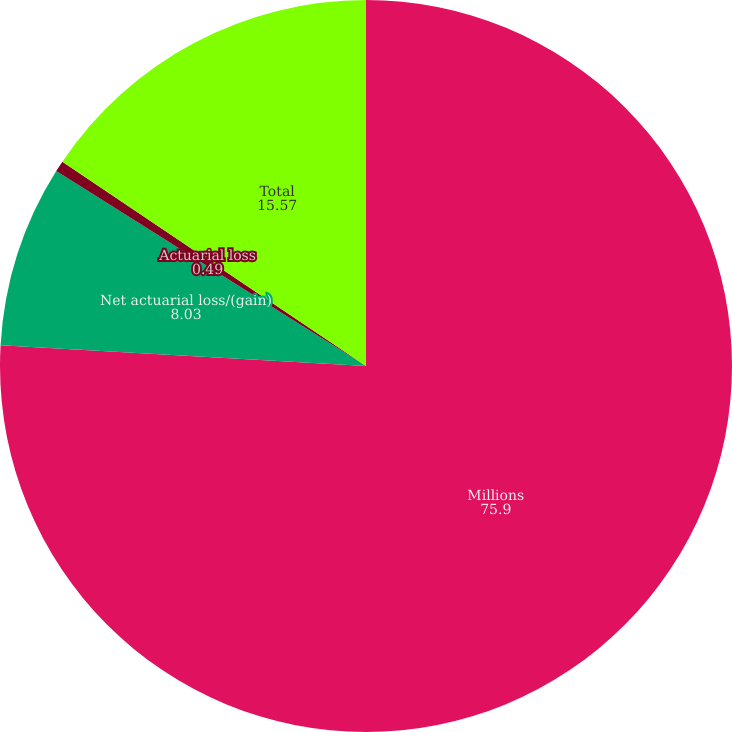Convert chart to OTSL. <chart><loc_0><loc_0><loc_500><loc_500><pie_chart><fcel>Millions<fcel>Net actuarial loss/(gain)<fcel>Actuarial loss<fcel>Total<nl><fcel>75.9%<fcel>8.03%<fcel>0.49%<fcel>15.57%<nl></chart> 